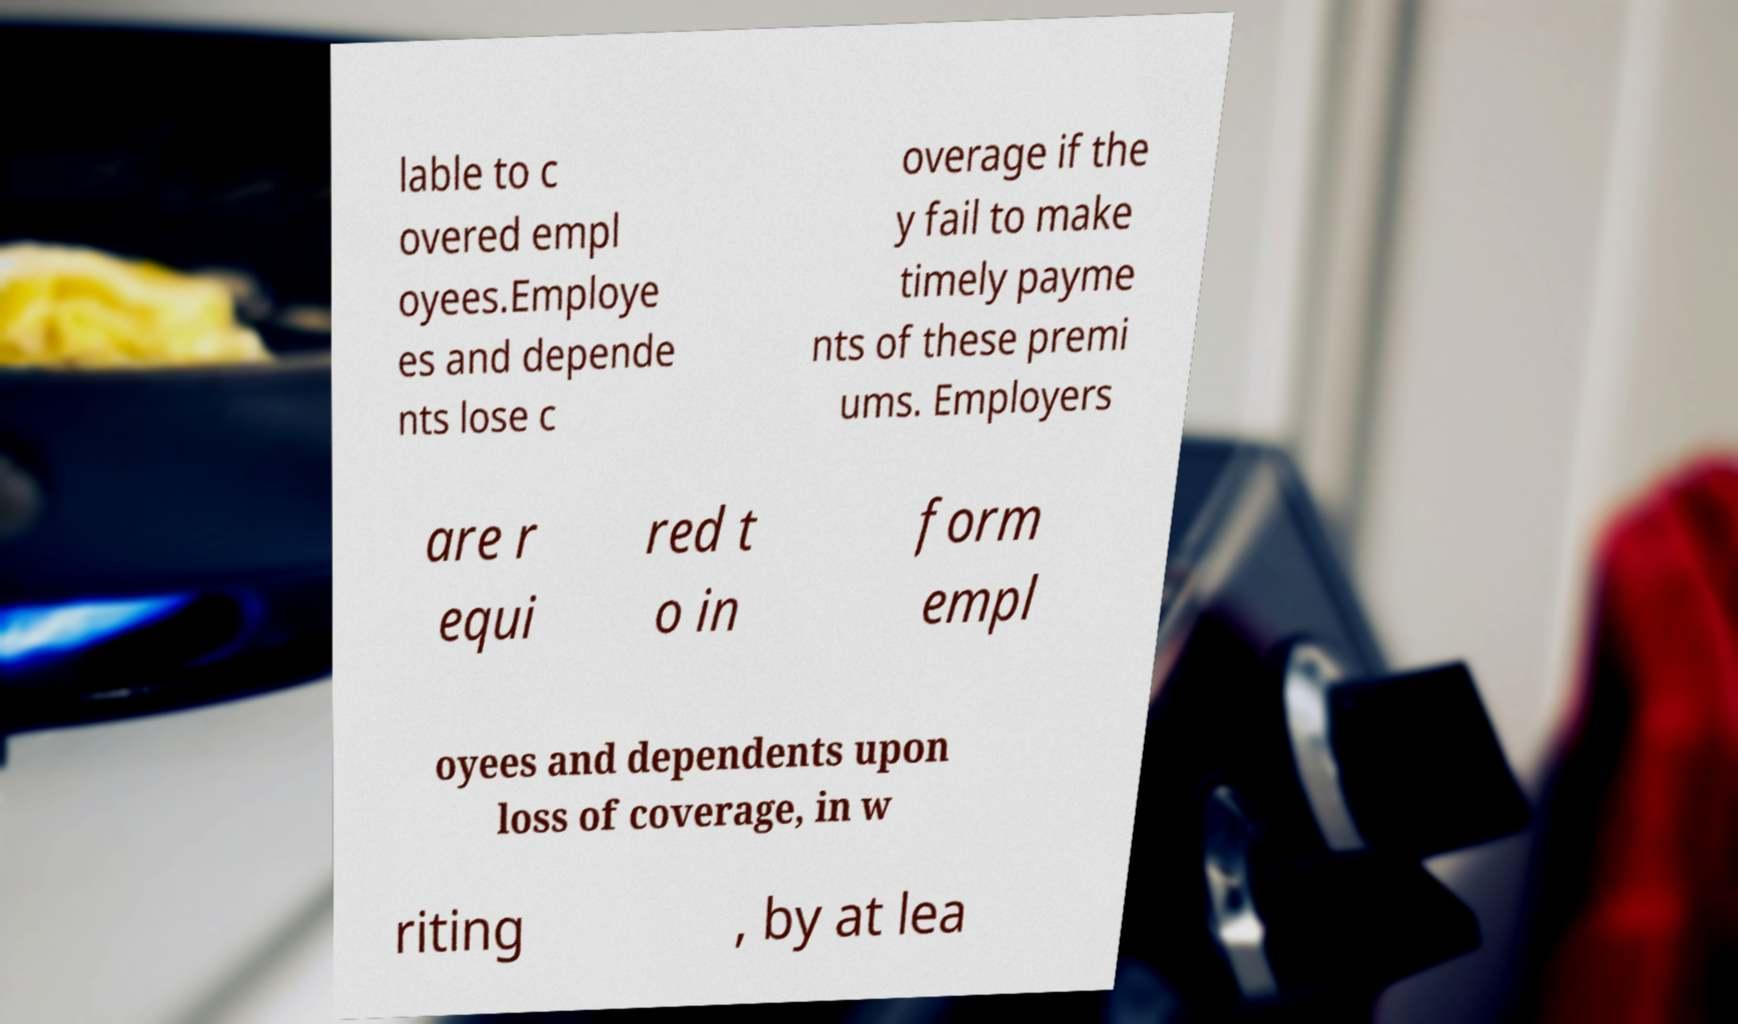There's text embedded in this image that I need extracted. Can you transcribe it verbatim? lable to c overed empl oyees.Employe es and depende nts lose c overage if the y fail to make timely payme nts of these premi ums. Employers are r equi red t o in form empl oyees and dependents upon loss of coverage, in w riting , by at lea 